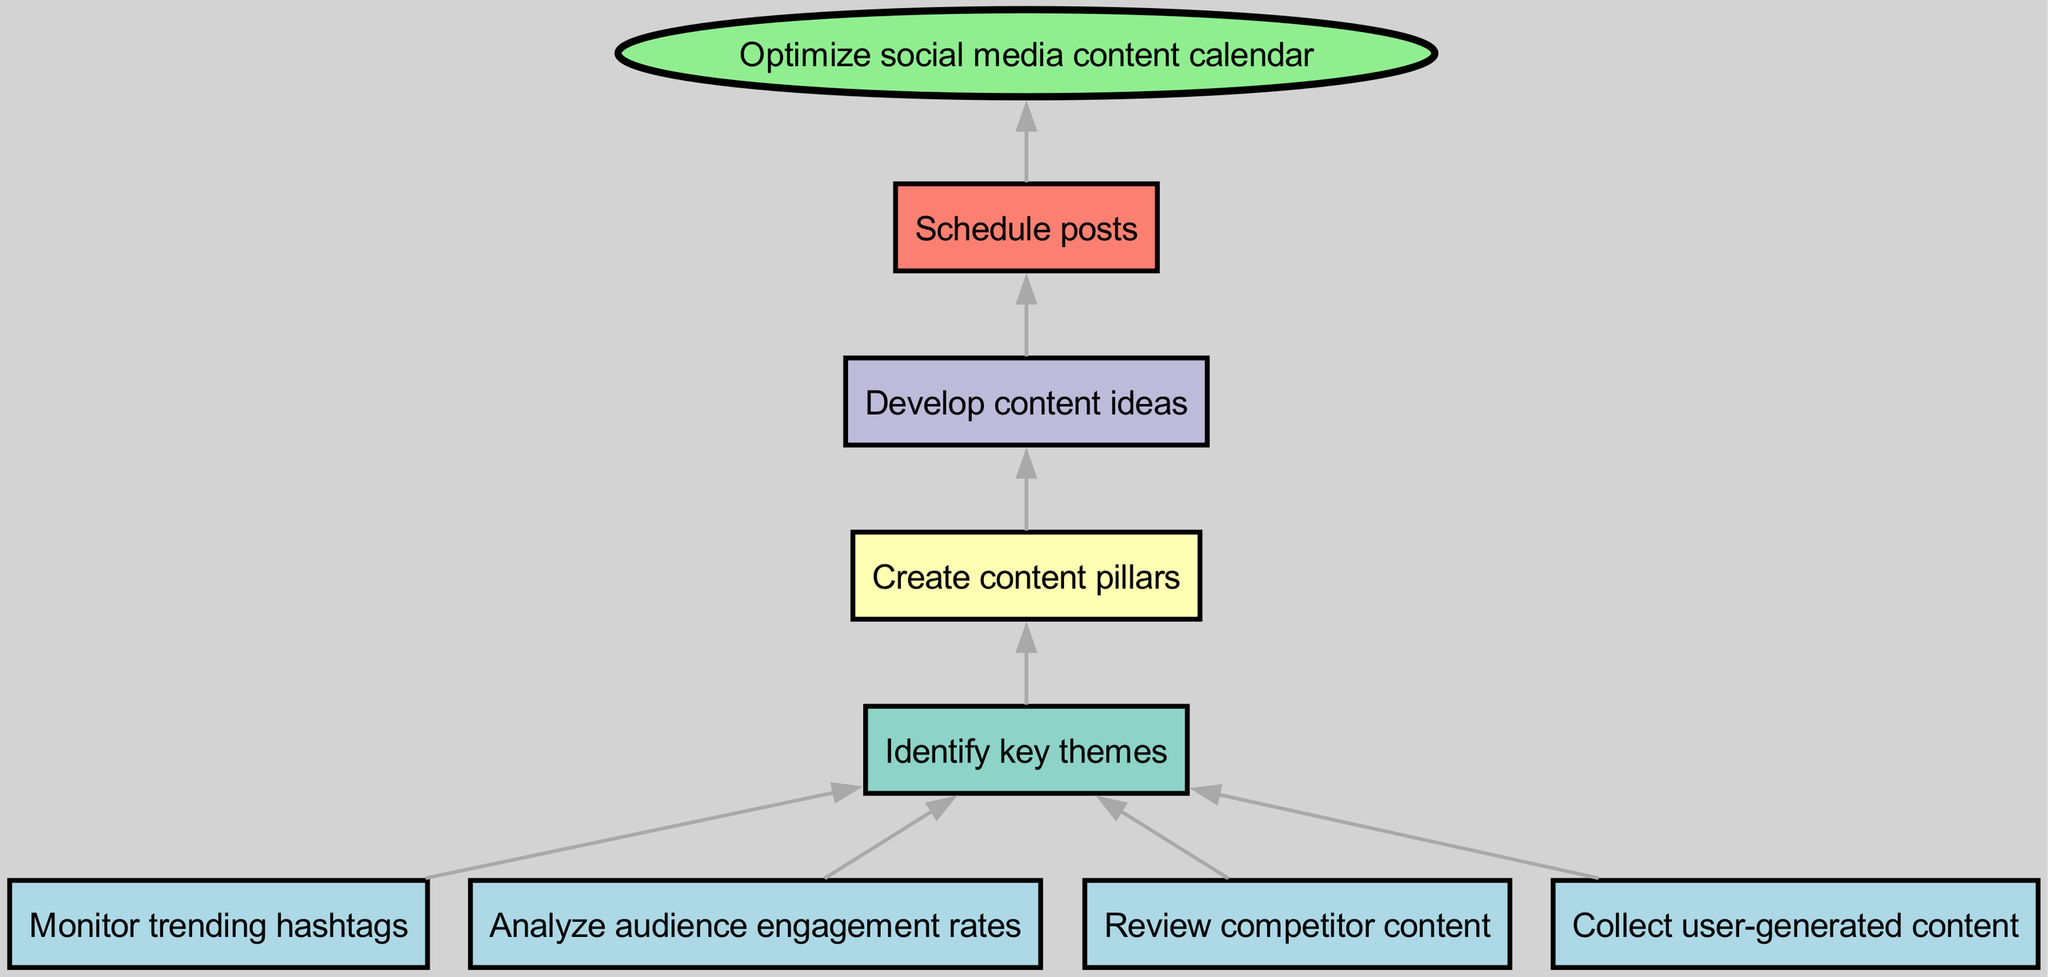What are the starting nodes of the diagram? The starting nodes are the initial points of the process, which include monitoring trending hashtags, analyzing audience engagement rates, reviewing competitor content, and collecting user-generated content.
Answer: Monitor trending hashtags, Analyze audience engagement rates, Review competitor content, Collect user-generated content How many intermediate nodes are in the diagram? The intermediate nodes represent steps that occur after the start nodes and before reaching the end node. There are four intermediate nodes identified as key themes, content pillars, content ideas, and scheduled posts.
Answer: 4 What is the end node of the flow chart? The end node signifies the final outcome of the flow chart process, demonstrating what is achieved after the preceding steps. In this case, it is optimizing the social media content calendar.
Answer: Optimize social media content calendar Which node comes after creating content pillars? To determine this, we examine the connections in the diagram. After creating content pillars, the subsequent node is to develop content ideas.
Answer: Develop content ideas What connections lead to the identification of key themes? This asks for the initial steps that impact the identification of key themes, which includes monitoring trending hashtags, analyzing audience engagement rates, reviewing competitor content, and collecting user-generated content.
Answer: Monitor trending hashtags, Analyze audience engagement rates, Review competitor content, Collect user-generated content How does the creation of content pillars influence the next steps? The creation of content pillars acts as a foundation for further development, specifically leading to the generation of content ideas. This relationship illustrates that content pillars guide the subsequent creativity.
Answer: Develop content ideas What type of flow chart is this? Since the chart represents a process that begins with various inputs and builds up to a single outcome, it is classified as a bottom-up flow chart.
Answer: Bottom-up flow chart What is the relationship between scheduling posts and optimizing the calendar? The relationship indicates that scheduling posts is a step that directly leads to the final result of optimizing the social media content calendar, highlighting the sequential process of reaching the end goal.
Answer: Optimize social media content calendar 